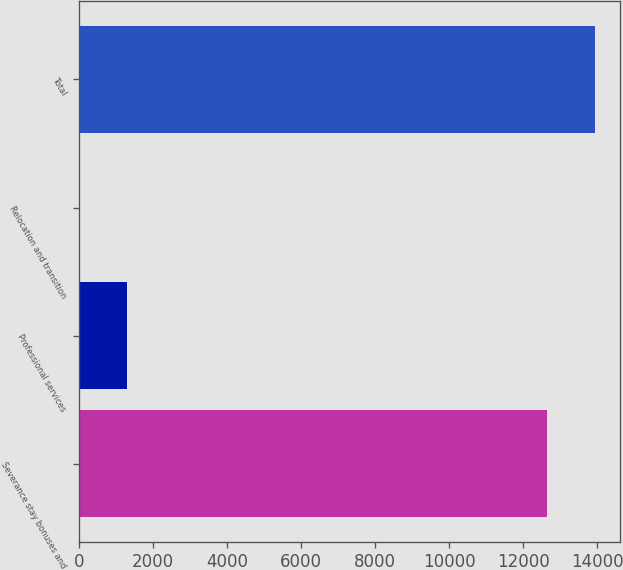Convert chart. <chart><loc_0><loc_0><loc_500><loc_500><bar_chart><fcel>Severance stay bonuses and<fcel>Professional services<fcel>Relocation and transition<fcel>Total<nl><fcel>12641<fcel>1303.7<fcel>20<fcel>13924.7<nl></chart> 